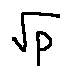<formula> <loc_0><loc_0><loc_500><loc_500>\sqrt { p }</formula> 